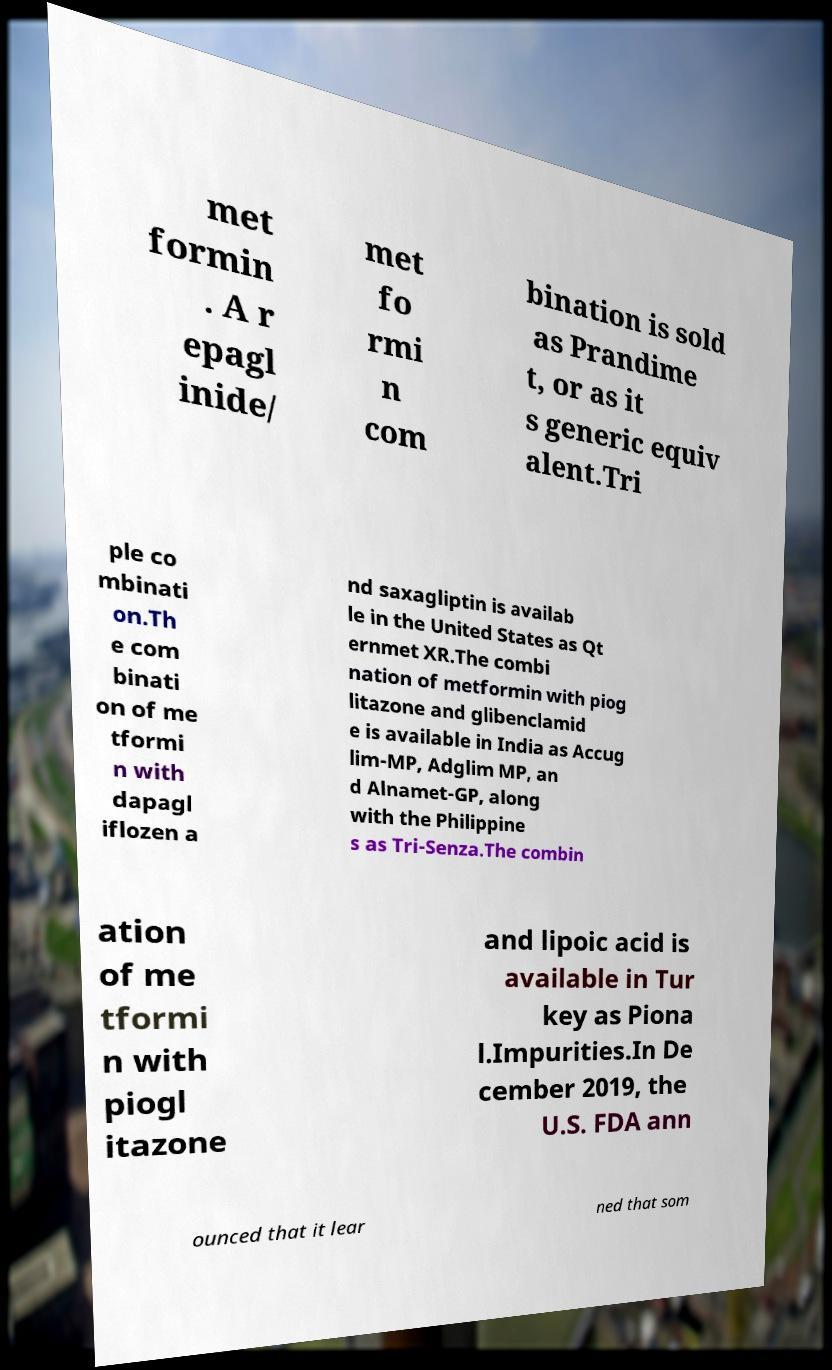Could you extract and type out the text from this image? met formin . A r epagl inide/ met fo rmi n com bination is sold as Prandime t, or as it s generic equiv alent.Tri ple co mbinati on.Th e com binati on of me tformi n with dapagl iflozen a nd saxagliptin is availab le in the United States as Qt ernmet XR.The combi nation of metformin with piog litazone and glibenclamid e is available in India as Accug lim-MP, Adglim MP, an d Alnamet-GP, along with the Philippine s as Tri-Senza.The combin ation of me tformi n with piogl itazone and lipoic acid is available in Tur key as Piona l.Impurities.In De cember 2019, the U.S. FDA ann ounced that it lear ned that som 